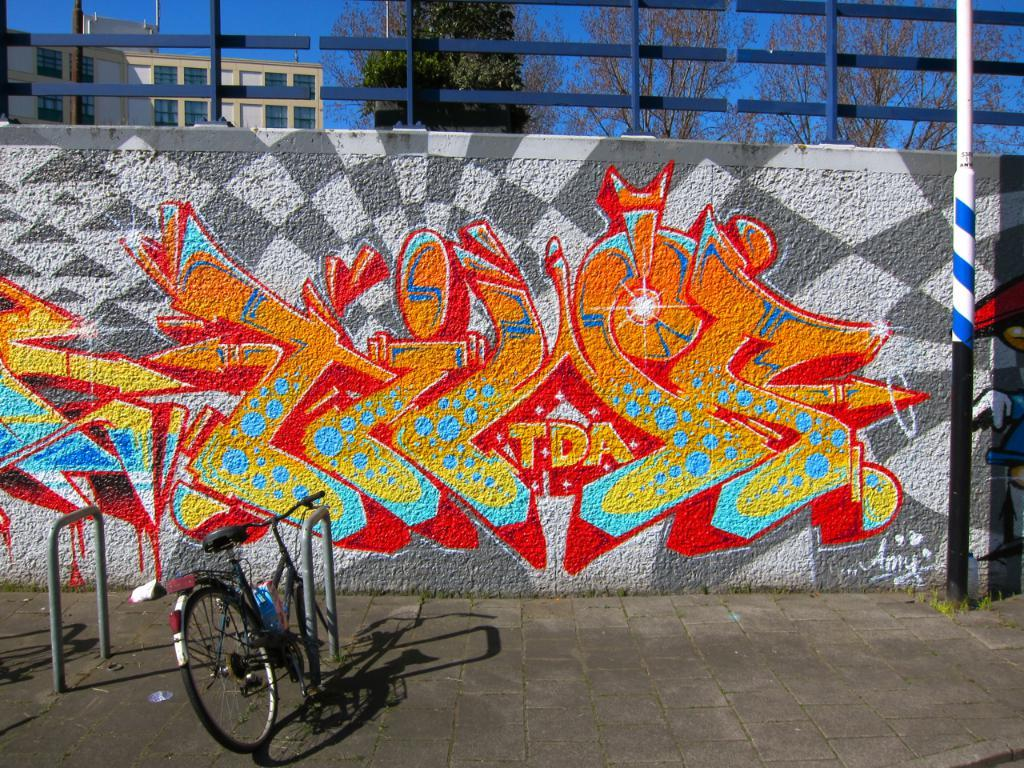What is present on the wall in the image? There are paintings on the wall in the image. What is parked in front of the wall? There is a cycle parked on a path in front of the wall. What can be seen in the background of the image? There is a building and trees in the background of the image. What type of clouds can be seen in the image? There are no clouds visible in the image. Who is the parent of the person holding the camera in the image? There is no camera or person holding a camera present in the image. 